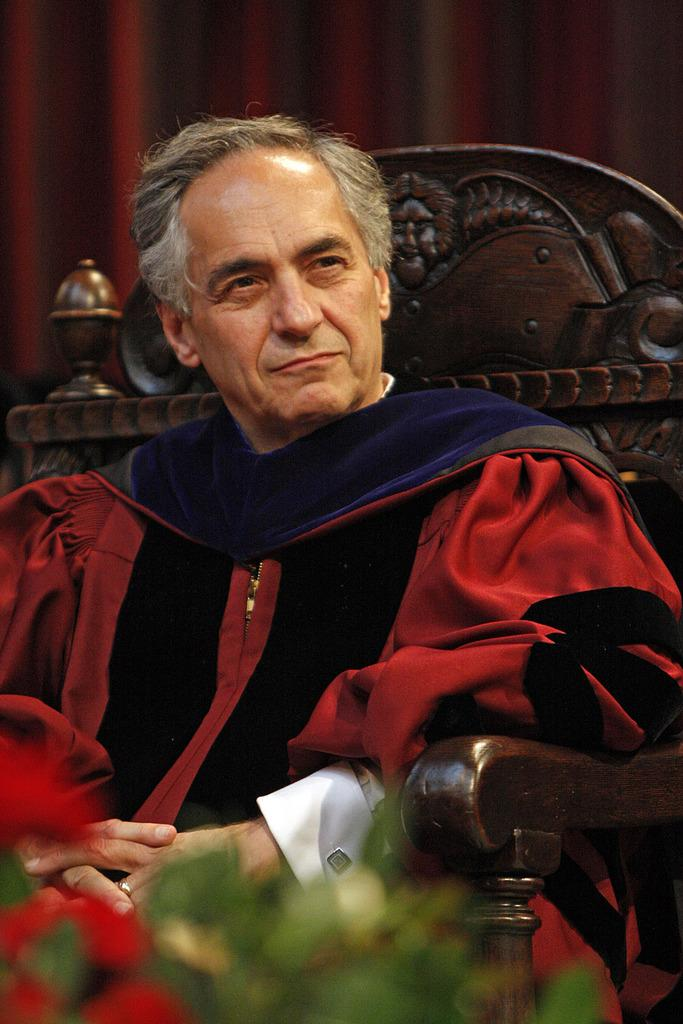Who is the main subject in the image? There is an old man in the image. What is the old man wearing? The old man is wearing a red dress. What is the old man doing in the image? The old man is sitting on a chair. What can be seen in the front of the image? There is a flower bouquet in the front of the image. What is present in the back of the image? There is a curtain in the back of the image. What type of space suit is the old man wearing in the image? The old man is not wearing a space suit in the image; he is wearing a red dress. Can you see any stamps on the curtain in the image? There are no stamps visible on the curtain in the image. 